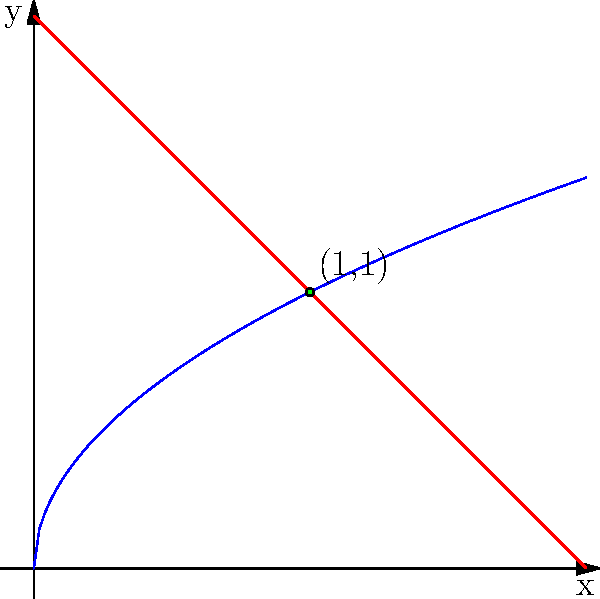A machine part needs to be designed in the shape of a rectangle with one curved side. The curved side is described by the function $y = \sqrt{x}$, and the opposite side is given by the line $y = 2-x$. What dimensions should the part have to minimize the area while ensuring that the width (along the x-axis) is at least 0.5 units? Express your answer in terms of the optimal width. To solve this optimization problem, we'll follow these steps:

1) The area of the part is given by the integral:
   $$A = \int_0^w (2-x) - \sqrt{x} dx$$
   where $w$ is the width of the part.

2) Expand the integrand:
   $$A = \int_0^w (2-x-\sqrt{x}) dx$$

3) Integrate:
   $$A = [2x - \frac{x^2}{2} - \frac{2x^{3/2}}{3}]_0^w$$
   $$A = 2w - \frac{w^2}{2} - \frac{2w^{3/2}}{3}$$

4) To find the minimum, differentiate with respect to $w$ and set to zero:
   $$\frac{dA}{dw} = 2 - w - w^{1/2} = 0$$

5) Rearrange:
   $$w^{1/2} = 2 - w$$
   $$w = (2-w)^2$$
   $$w = 4 - 4w + w^2$$
   $$0 = 4 - 5w + w^2$$
   $$w^2 - 5w + 4 = 0$$

6) Solve this quadratic equation:
   $$w = \frac{5 \pm \sqrt{25-16}}{2} = \frac{5 \pm 3}{2}$$

7) This gives us two solutions: $w = 4$ or $w = 1$

8) The second derivative test confirms that $w = 1$ gives the minimum area.

9) Check the constraint: The width must be at least 0.5 units. Since 1 > 0.5, this solution satisfies the constraint.

Therefore, the optimal width is 1 unit.
Answer: 1 unit 